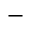Convert formula to latex. <formula><loc_0><loc_0><loc_500><loc_500>^ { - }</formula> 